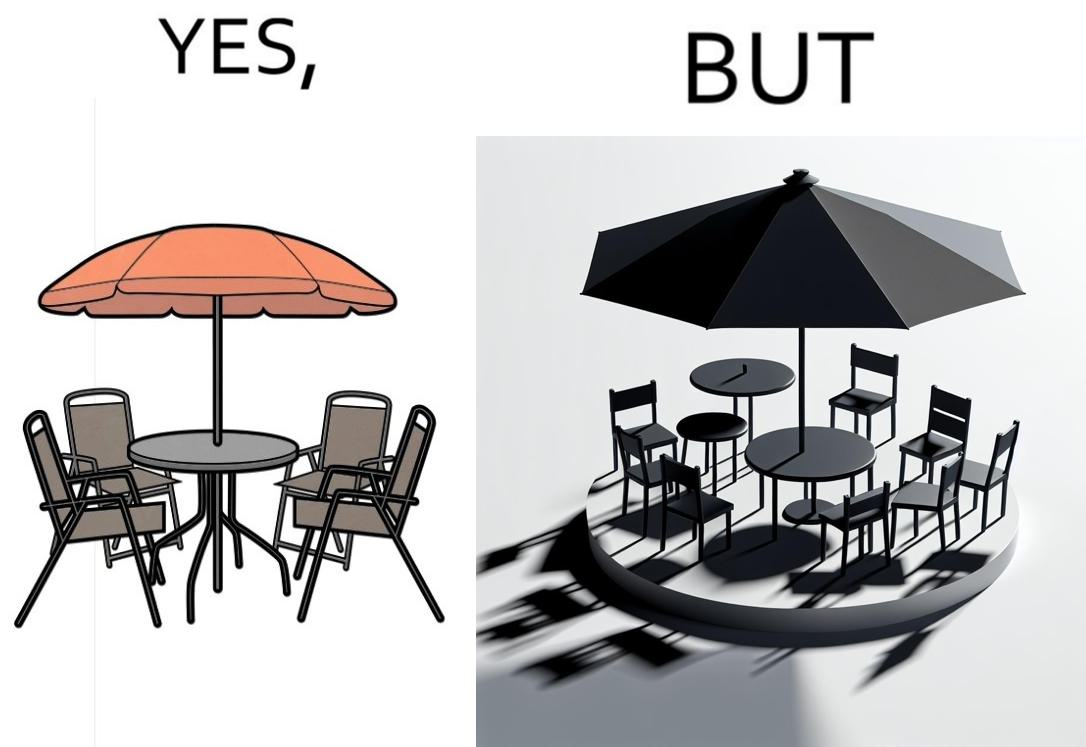Why is this image considered satirical? The image is ironical, as the umbrella is meant to provide shadow in the area where the chairs are present, but due to the orientation of the rays of the sun, all the chairs are in sunlight, and the umbrella is of no use in this situation. 